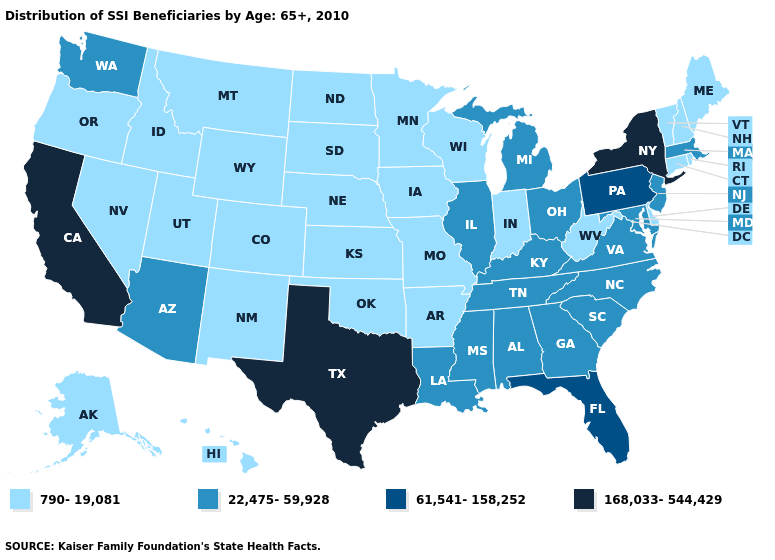Does Washington have a lower value than California?
Concise answer only. Yes. Name the states that have a value in the range 168,033-544,429?
Quick response, please. California, New York, Texas. Does the map have missing data?
Write a very short answer. No. Name the states that have a value in the range 22,475-59,928?
Quick response, please. Alabama, Arizona, Georgia, Illinois, Kentucky, Louisiana, Maryland, Massachusetts, Michigan, Mississippi, New Jersey, North Carolina, Ohio, South Carolina, Tennessee, Virginia, Washington. What is the lowest value in the MidWest?
Write a very short answer. 790-19,081. What is the value of North Carolina?
Be succinct. 22,475-59,928. Does the first symbol in the legend represent the smallest category?
Short answer required. Yes. What is the value of New Jersey?
Answer briefly. 22,475-59,928. Name the states that have a value in the range 61,541-158,252?
Answer briefly. Florida, Pennsylvania. What is the value of Alaska?
Write a very short answer. 790-19,081. Does Alabama have a lower value than Minnesota?
Quick response, please. No. What is the value of Wyoming?
Answer briefly. 790-19,081. What is the value of Mississippi?
Quick response, please. 22,475-59,928. What is the highest value in the USA?
Answer briefly. 168,033-544,429. 